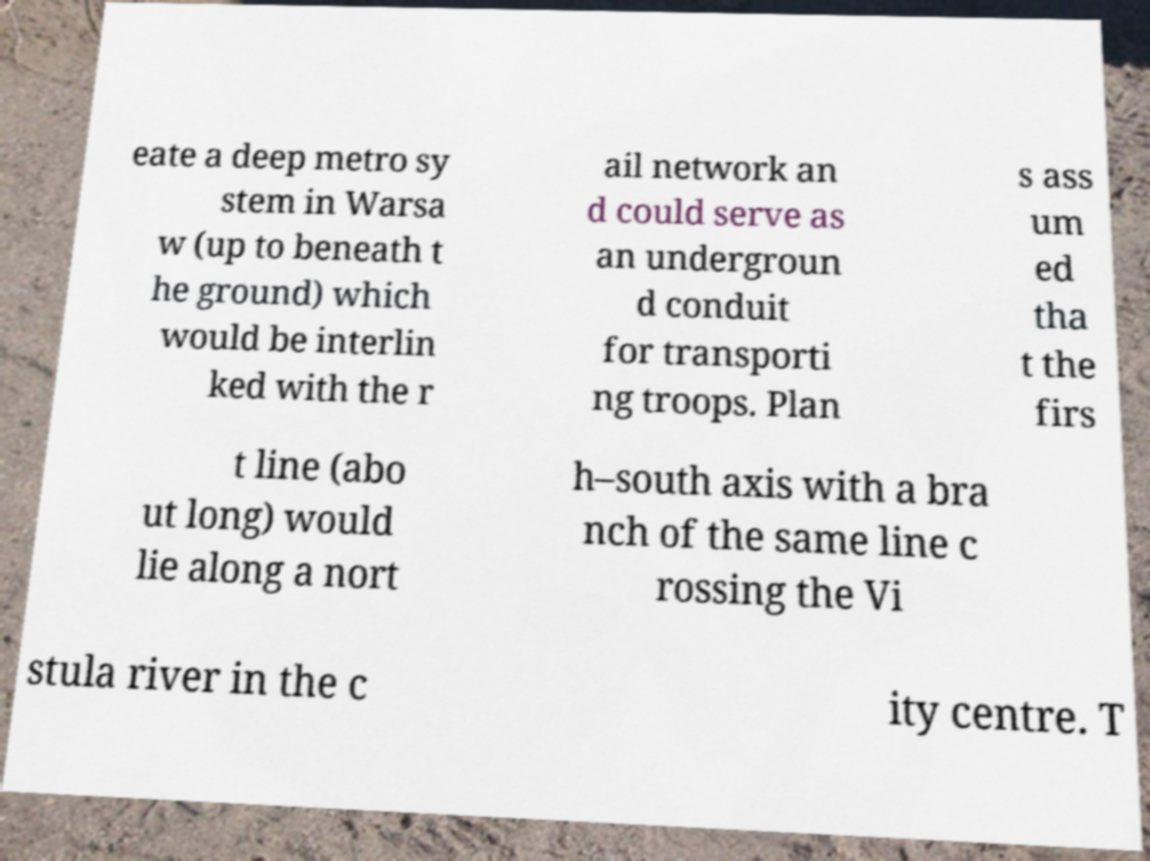Please read and relay the text visible in this image. What does it say? eate a deep metro sy stem in Warsa w (up to beneath t he ground) which would be interlin ked with the r ail network an d could serve as an undergroun d conduit for transporti ng troops. Plan s ass um ed tha t the firs t line (abo ut long) would lie along a nort h–south axis with a bra nch of the same line c rossing the Vi stula river in the c ity centre. T 